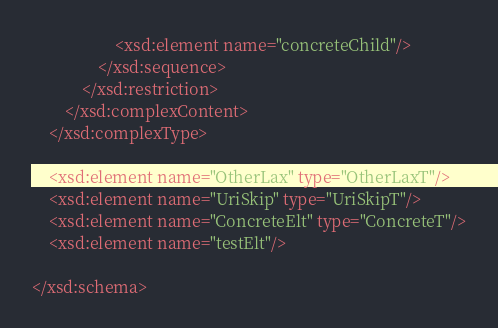Convert code to text. <code><loc_0><loc_0><loc_500><loc_500><_XML_>                    <xsd:element name="concreteChild"/>
                </xsd:sequence>
            </xsd:restriction>
        </xsd:complexContent>
    </xsd:complexType>

    <xsd:element name="OtherLax" type="OtherLaxT"/>
    <xsd:element name="UriSkip" type="UriSkipT"/>
    <xsd:element name="ConcreteElt" type="ConcreteT"/>
    <xsd:element name="testElt"/>

</xsd:schema></code> 